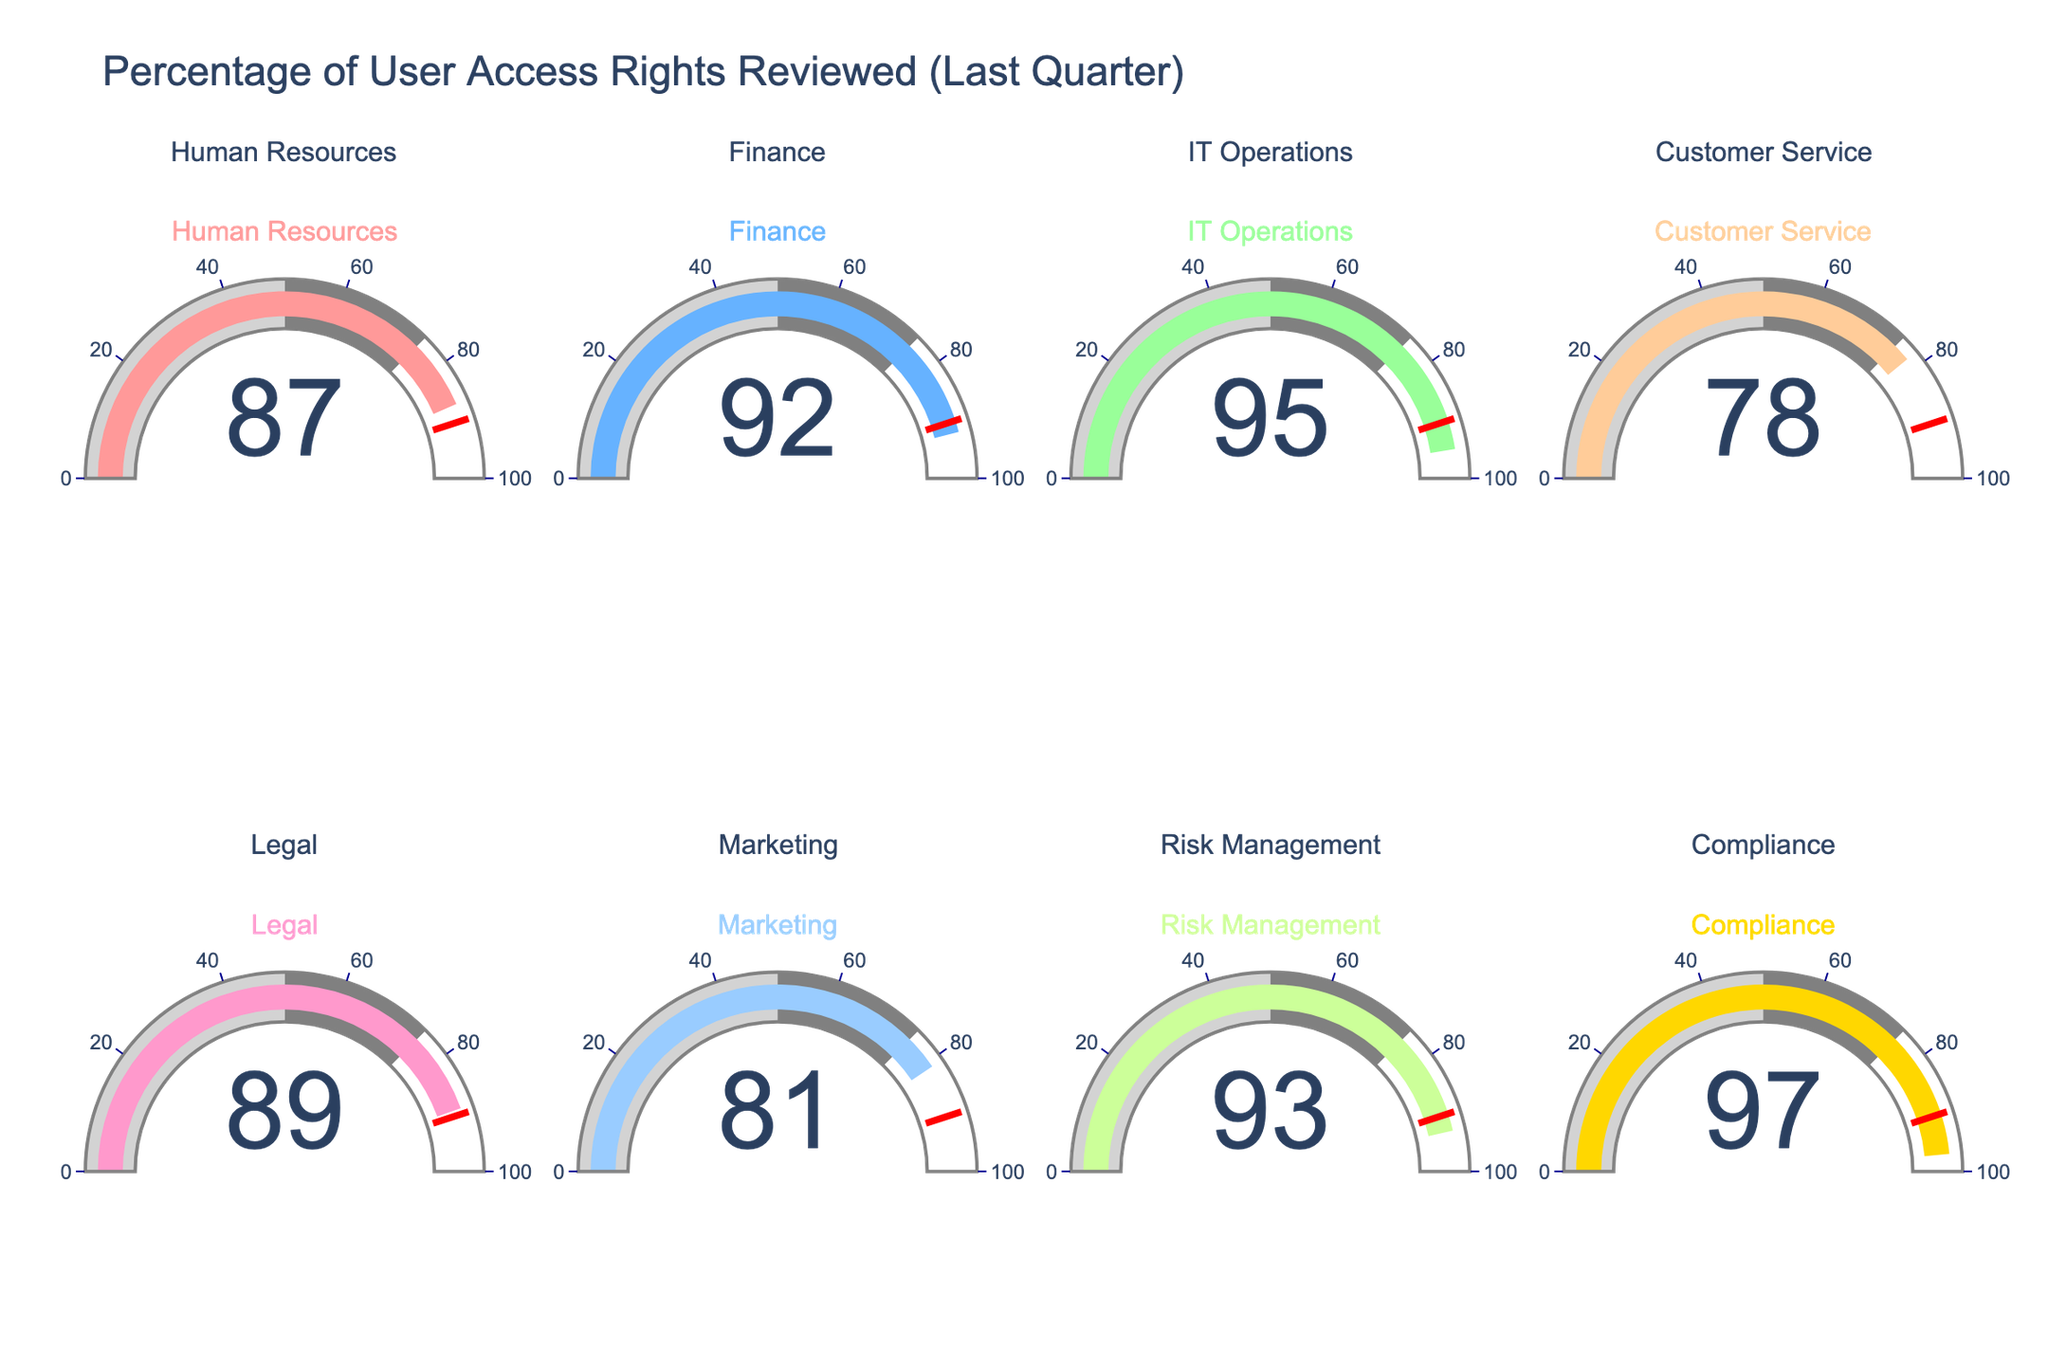What's the highest percentage of user access rights reviewed among all departments? Look at all the values displayed on the gauges and identify the highest one, which is found on the Compliance gauge showing 97%.
Answer: 97% Which department has the lowest percentage of user access rights reviewed? Compare the percentage values for each department and identify the lowest one, which is the Customer Service department with 78%.
Answer: Customer Service How many departments reviewed at least 90% of user access rights? Count the number of departments with percentages 90 or above: Finance (92), IT Operations (95), Risk Management (93), and Compliance (97). There are 4 departments.
Answer: 4 What's the average percentage of user access rights reviewed across all departments? Sum all percentages: (87+92+95+78+89+81+93+97) = 712, then divide by the number of departments (8). The average is 712/8 = 89%.
Answer: 89% Which department is just below the threshold value of 90%? The graphs have a threshold line marked at 90%. The department nearest and just below this threshold is Human Resources with 87%.
Answer: Human Resources Is there any department with exactly 90% reviewed user access rights? Check all the displayed values to see if any gauge shows exactly 90%. None of them do.
Answer: No What is the percentage difference between the department with the highest and the lowest reviewed user access rights? Subtract the lowest percentage (78% for Customer Service) from the highest (97% for Compliance): 97 - 78 = 19.
Answer: 19 Which departments have percentages within the 80-90% range? Identify departments with values between 80 and 89 inclusive. The departments fitting this range are Human Resources (87), Legal (89), and Marketing (81).
Answer: Human Resources, Legal, Marketing How many departments have reviewed less than 85% of user access rights? Count the number of departments with percentages below 85. Only two departments meet this criterion: Customer Service (78) and Marketing (81).
Answer: 2 